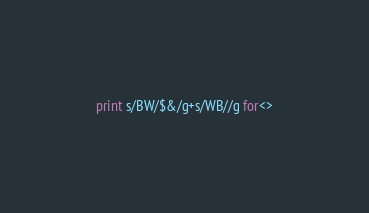<code> <loc_0><loc_0><loc_500><loc_500><_Perl_>print s/BW/$&/g+s/WB//g for<></code> 